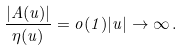Convert formula to latex. <formula><loc_0><loc_0><loc_500><loc_500>\frac { | A ( u ) | } { \eta ( u ) } = o ( 1 ) | u | \to \infty \, .</formula> 